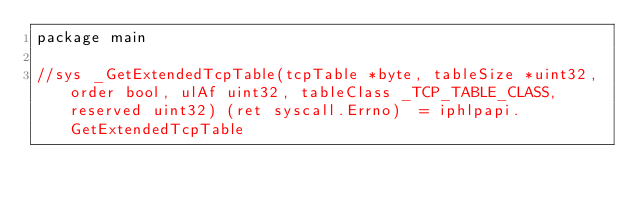Convert code to text. <code><loc_0><loc_0><loc_500><loc_500><_Go_>package main

//sys _GetExtendedTcpTable(tcpTable *byte, tableSize *uint32, order bool, ulAf uint32, tableClass _TCP_TABLE_CLASS, reserved uint32) (ret syscall.Errno)  = iphlpapi.GetExtendedTcpTable
</code> 